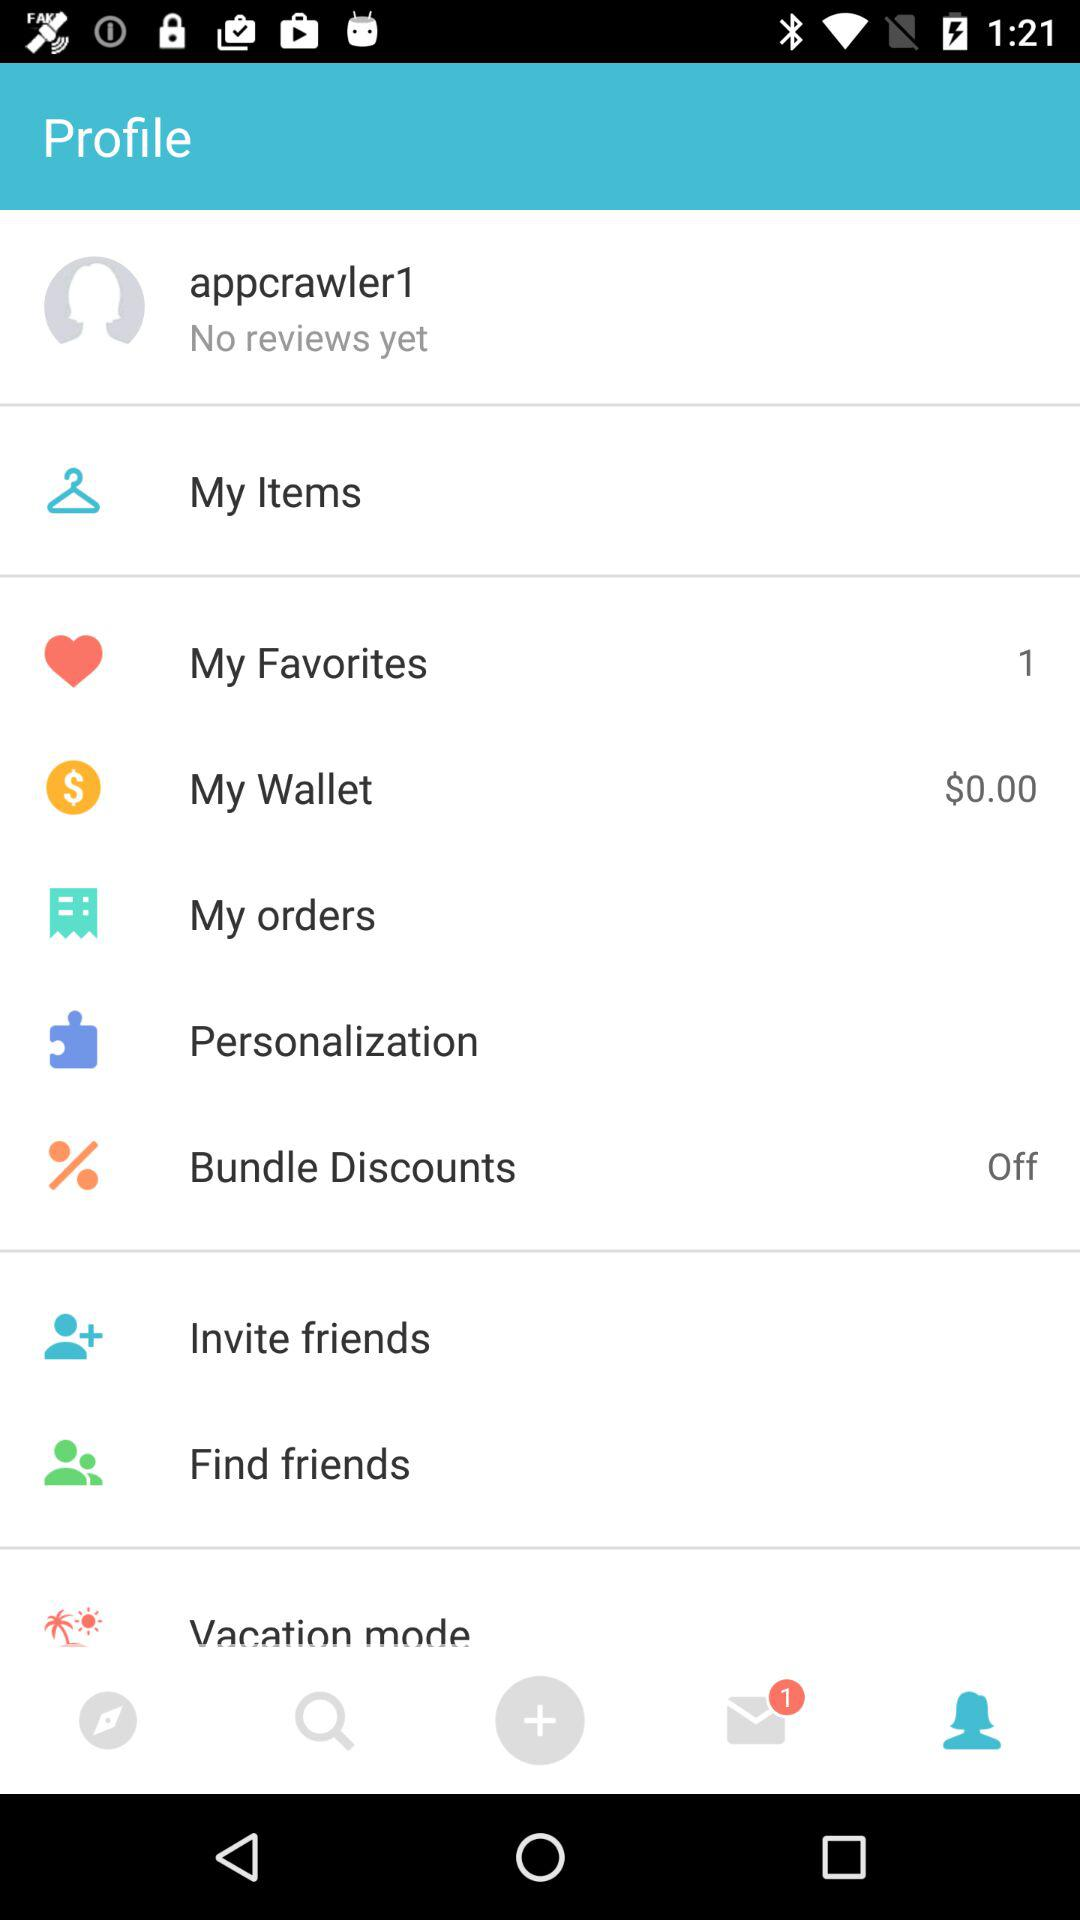How much money is in "My Wallet"? There is $0 in "My Wallet". 